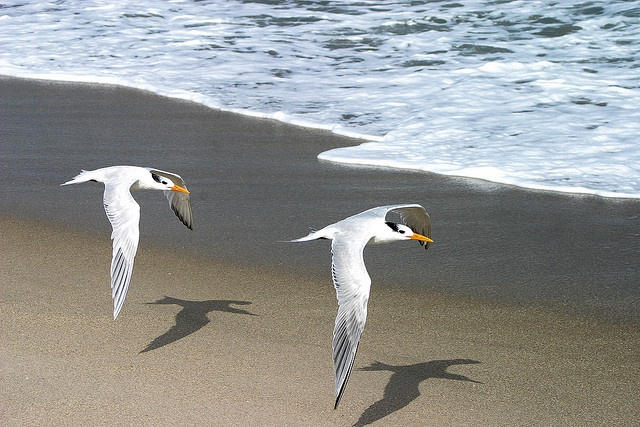Describe the objects in this image and their specific colors. I can see bird in lavender, lightgray, gray, darkgray, and black tones and bird in lavender, white, gray, and darkgray tones in this image. 